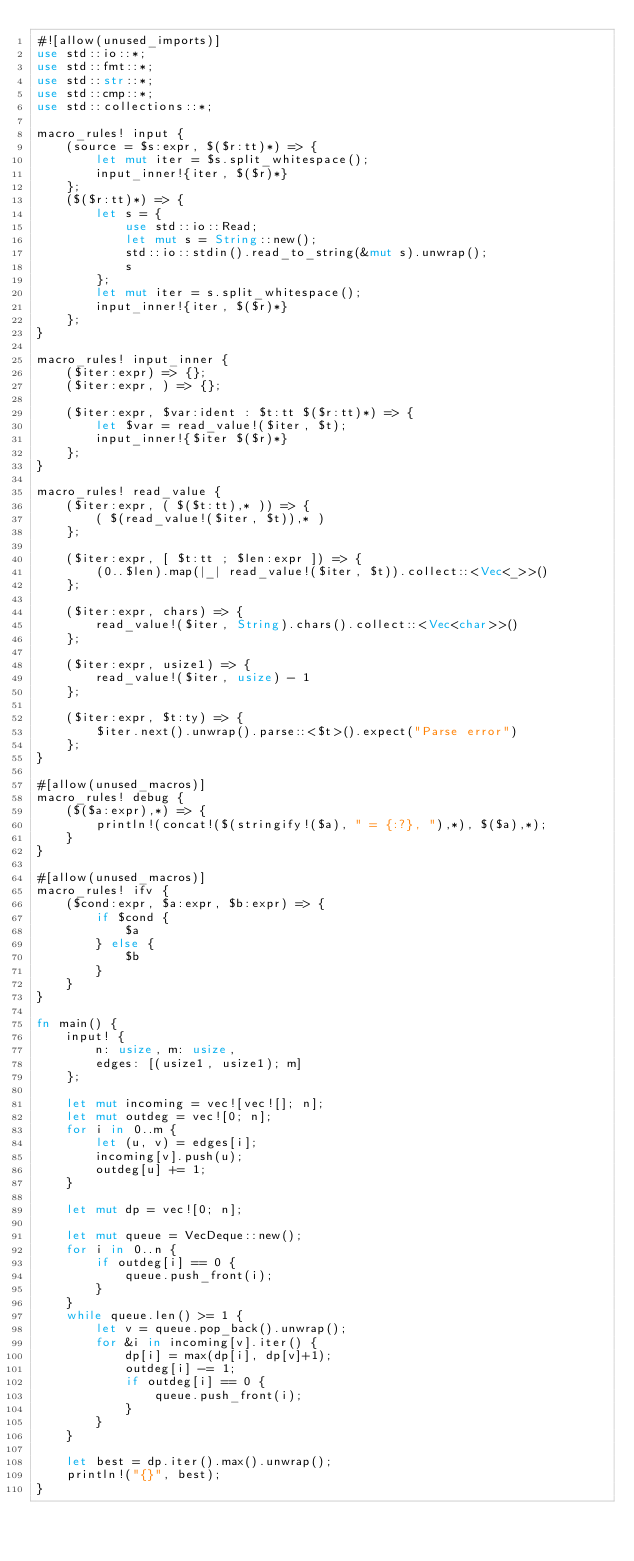<code> <loc_0><loc_0><loc_500><loc_500><_Rust_>#![allow(unused_imports)]
use std::io::*;
use std::fmt::*;
use std::str::*;
use std::cmp::*;
use std::collections::*;

macro_rules! input {
    (source = $s:expr, $($r:tt)*) => {
        let mut iter = $s.split_whitespace();
        input_inner!{iter, $($r)*}
    };
    ($($r:tt)*) => {
        let s = {
            use std::io::Read;
            let mut s = String::new();
            std::io::stdin().read_to_string(&mut s).unwrap();
            s
        };
        let mut iter = s.split_whitespace();
        input_inner!{iter, $($r)*}
    };
}

macro_rules! input_inner {
    ($iter:expr) => {};
    ($iter:expr, ) => {};

    ($iter:expr, $var:ident : $t:tt $($r:tt)*) => {
        let $var = read_value!($iter, $t);
        input_inner!{$iter $($r)*}
    };
}

macro_rules! read_value {
    ($iter:expr, ( $($t:tt),* )) => {
        ( $(read_value!($iter, $t)),* )
    };

    ($iter:expr, [ $t:tt ; $len:expr ]) => {
        (0..$len).map(|_| read_value!($iter, $t)).collect::<Vec<_>>()
    };

    ($iter:expr, chars) => {
        read_value!($iter, String).chars().collect::<Vec<char>>()
    };

    ($iter:expr, usize1) => {
        read_value!($iter, usize) - 1
    };

    ($iter:expr, $t:ty) => {
        $iter.next().unwrap().parse::<$t>().expect("Parse error")
    };
}

#[allow(unused_macros)]
macro_rules! debug {
    ($($a:expr),*) => {
        println!(concat!($(stringify!($a), " = {:?}, "),*), $($a),*);
    }
}

#[allow(unused_macros)]
macro_rules! ifv {
    ($cond:expr, $a:expr, $b:expr) => {
        if $cond {
            $a
        } else {
            $b
        }
    }
}

fn main() {
    input! {
        n: usize, m: usize,
        edges: [(usize1, usize1); m]
    };

    let mut incoming = vec![vec![]; n];
    let mut outdeg = vec![0; n];
    for i in 0..m {
        let (u, v) = edges[i];
        incoming[v].push(u);
        outdeg[u] += 1;
    }

    let mut dp = vec![0; n];

    let mut queue = VecDeque::new();
    for i in 0..n {
        if outdeg[i] == 0 {
            queue.push_front(i);
        }
    }
    while queue.len() >= 1 {
        let v = queue.pop_back().unwrap();
        for &i in incoming[v].iter() {
            dp[i] = max(dp[i], dp[v]+1);
            outdeg[i] -= 1;
            if outdeg[i] == 0 {
                queue.push_front(i);
            }
        }
    }

    let best = dp.iter().max().unwrap();
    println!("{}", best);
}</code> 